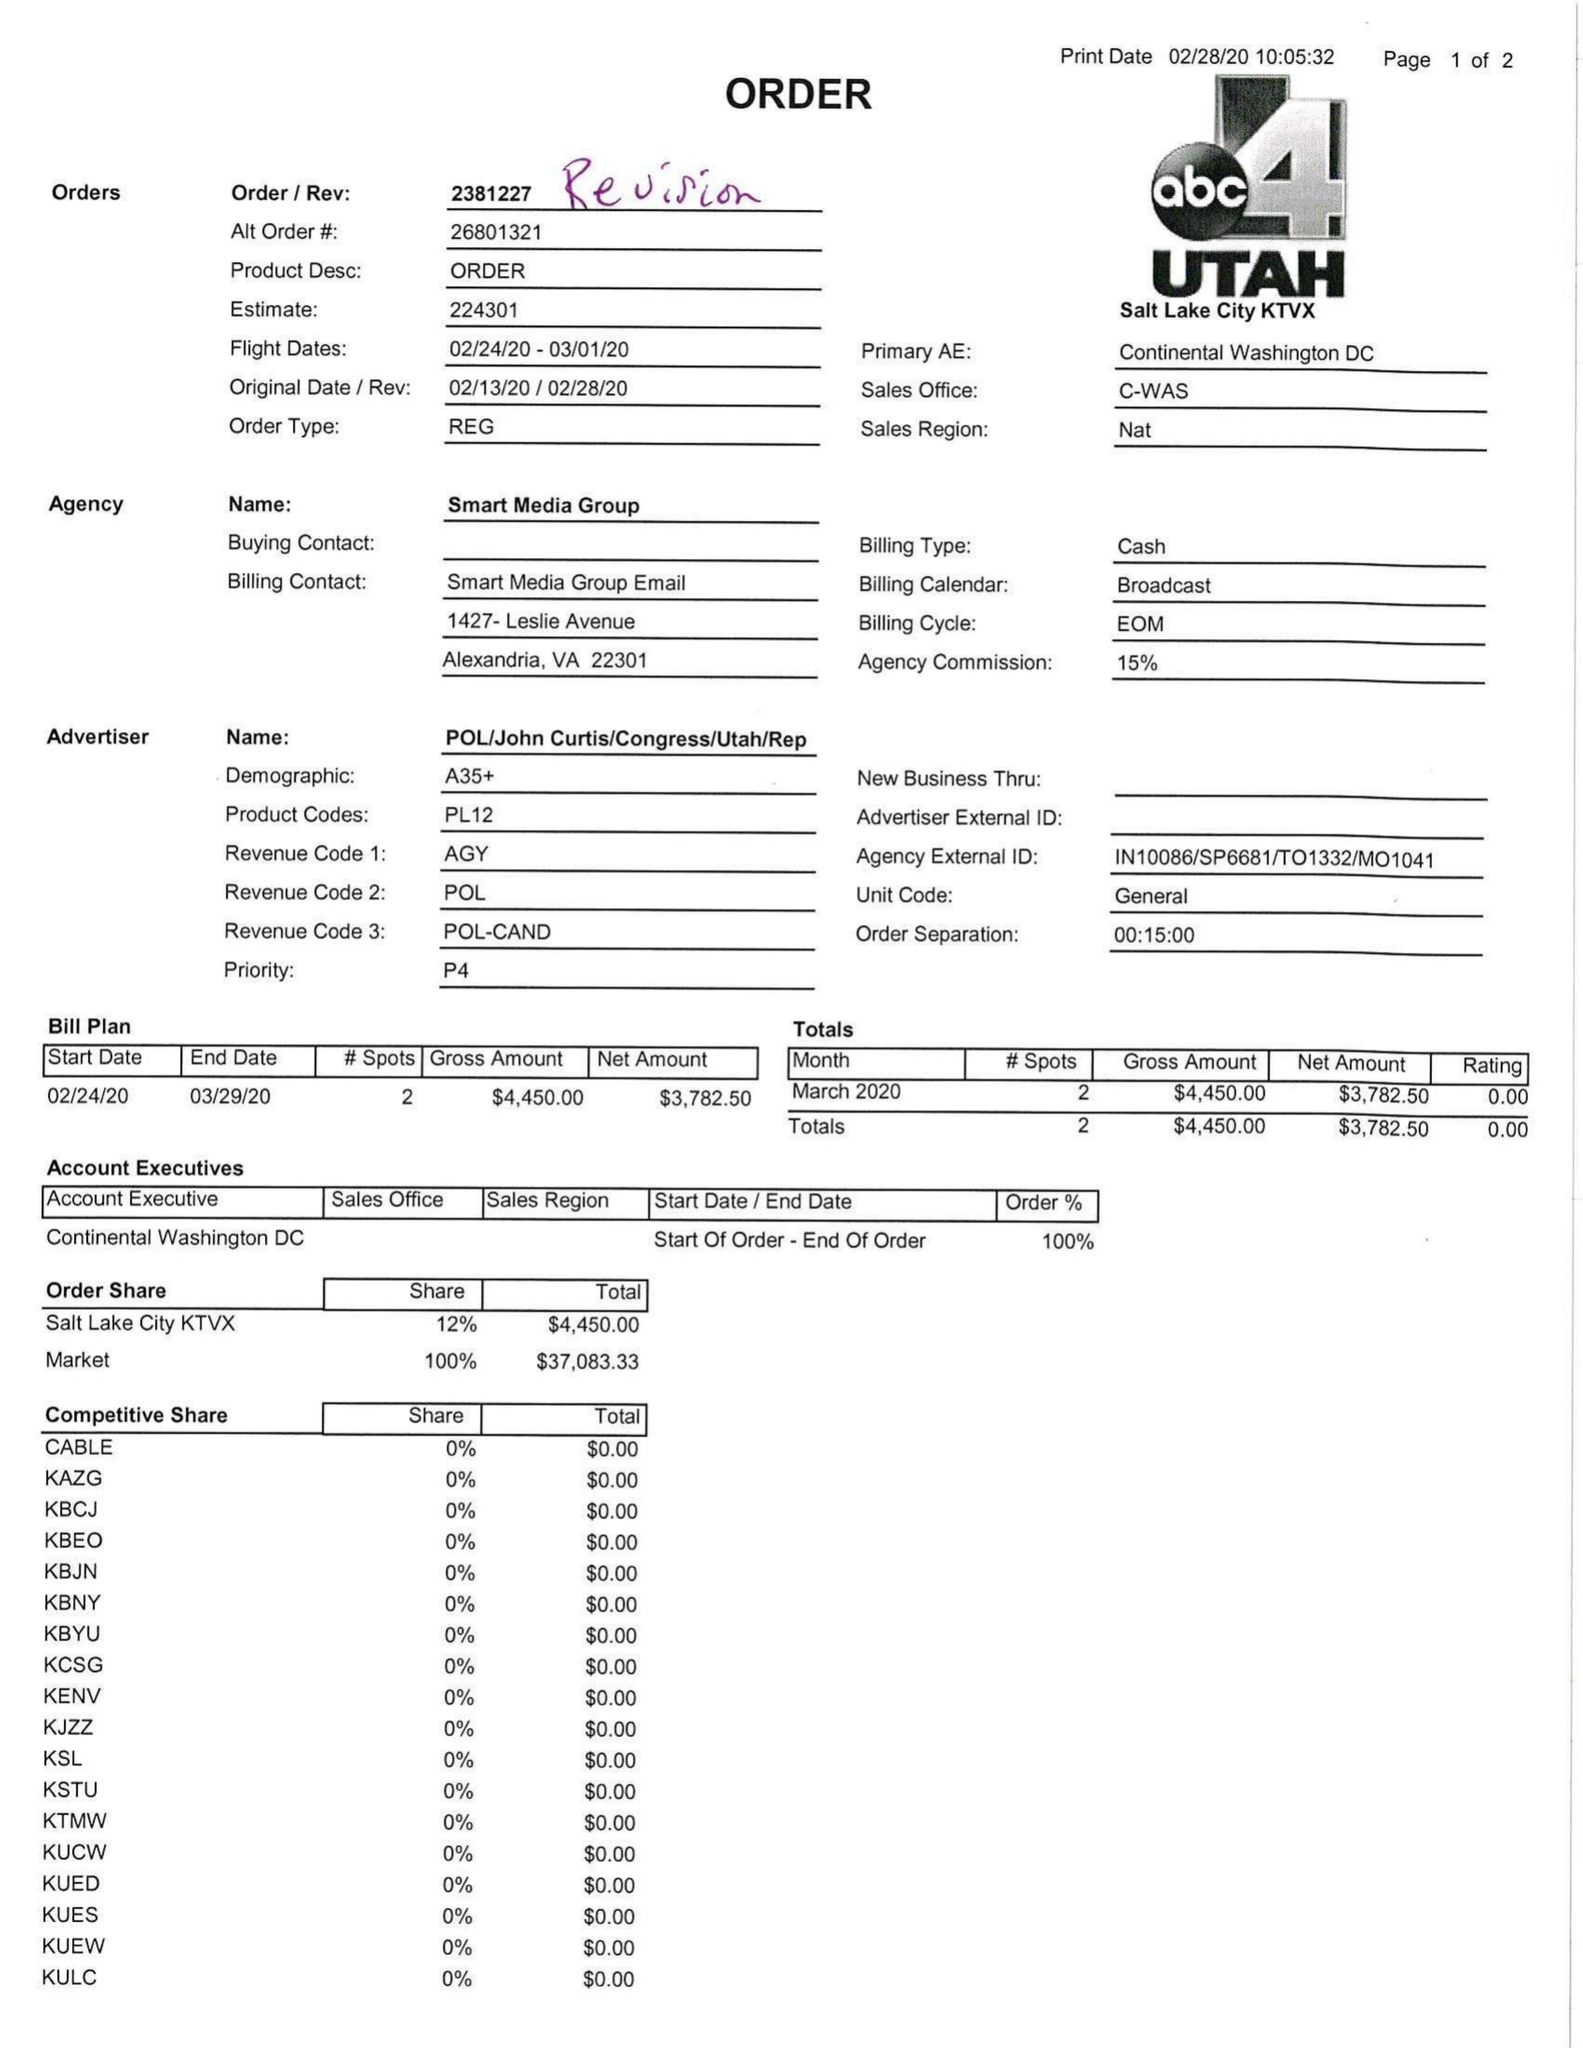What is the value for the advertiser?
Answer the question using a single word or phrase. POL/JOHNCURTIS/CONGRESS/UTAH/REP 